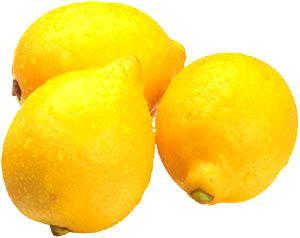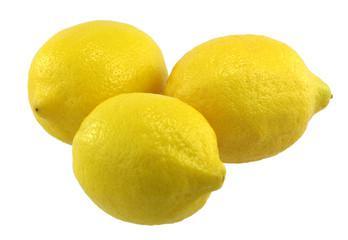The first image is the image on the left, the second image is the image on the right. Assess this claim about the two images: "In at least one image, there are three yellow lemons with at single stock of leaves next to the lemon on the left side.". Correct or not? Answer yes or no. No. The first image is the image on the left, the second image is the image on the right. Analyze the images presented: Is the assertion "Exactly one of the images of lemons includes leaves." valid? Answer yes or no. No. 